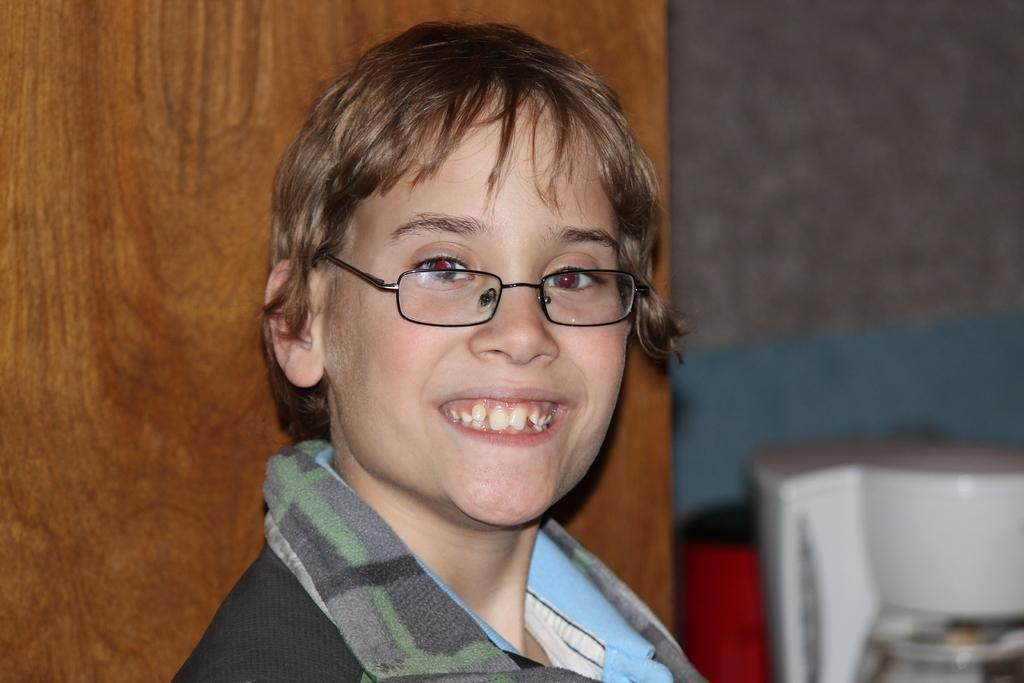Who is the main subject in the image? There is a woman in the center of the image. What is the woman wearing in the image? The woman is wearing spectacles in the image. What can be seen in the background of the image? There is a wall and objects visible in the background of the image. How many cherries are on the woman's head in the image? There are no cherries present on the woman's head in the image. 